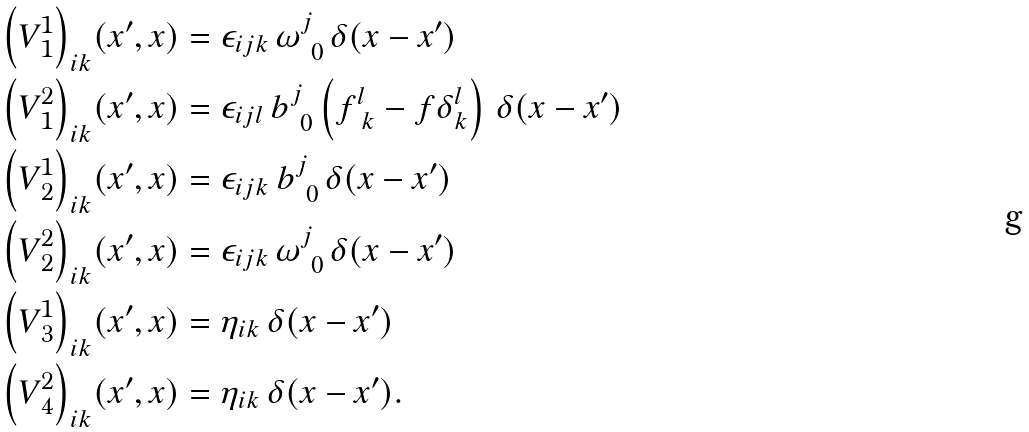<formula> <loc_0><loc_0><loc_500><loc_500>{ \left ( V ^ { 1 } _ { \, 1 } \right ) } _ { i k } ( x ^ { \prime } , x ) & = \epsilon _ { i j k } \, \omega ^ { j } _ { \ 0 } \, \delta ( x - x ^ { \prime } ) \\ { \left ( V ^ { 2 } _ { \, 1 } \right ) } _ { i k } ( x ^ { \prime } , x ) & = \epsilon _ { i j l } \, b ^ { j } _ { \ 0 } \left ( f ^ { l } _ { \ k } - f \delta ^ { l } _ { k } \right ) \, \delta ( x - x ^ { \prime } ) \\ { \left ( V ^ { 1 } _ { \, 2 } \right ) } _ { i k } ( x ^ { \prime } , x ) & = \epsilon _ { i j k } \, b ^ { j } _ { \ 0 } \, \delta ( x - x ^ { \prime } ) \\ { \left ( V ^ { 2 } _ { \, 2 } \right ) } _ { i k } ( x ^ { \prime } , x ) & = \epsilon _ { i j k } \, \omega ^ { j } _ { \ 0 } \, \delta ( x - x ^ { \prime } ) \\ { \left ( V ^ { 1 } _ { \, 3 } \right ) } _ { i k } ( x ^ { \prime } , x ) & = \eta _ { i k } \, \delta ( x - x ^ { \prime } ) \\ { \left ( V ^ { 2 } _ { \, 4 } \right ) } _ { i k } ( x ^ { \prime } , x ) & = \eta _ { i k } \, \delta ( x - x ^ { \prime } ) . \\</formula> 